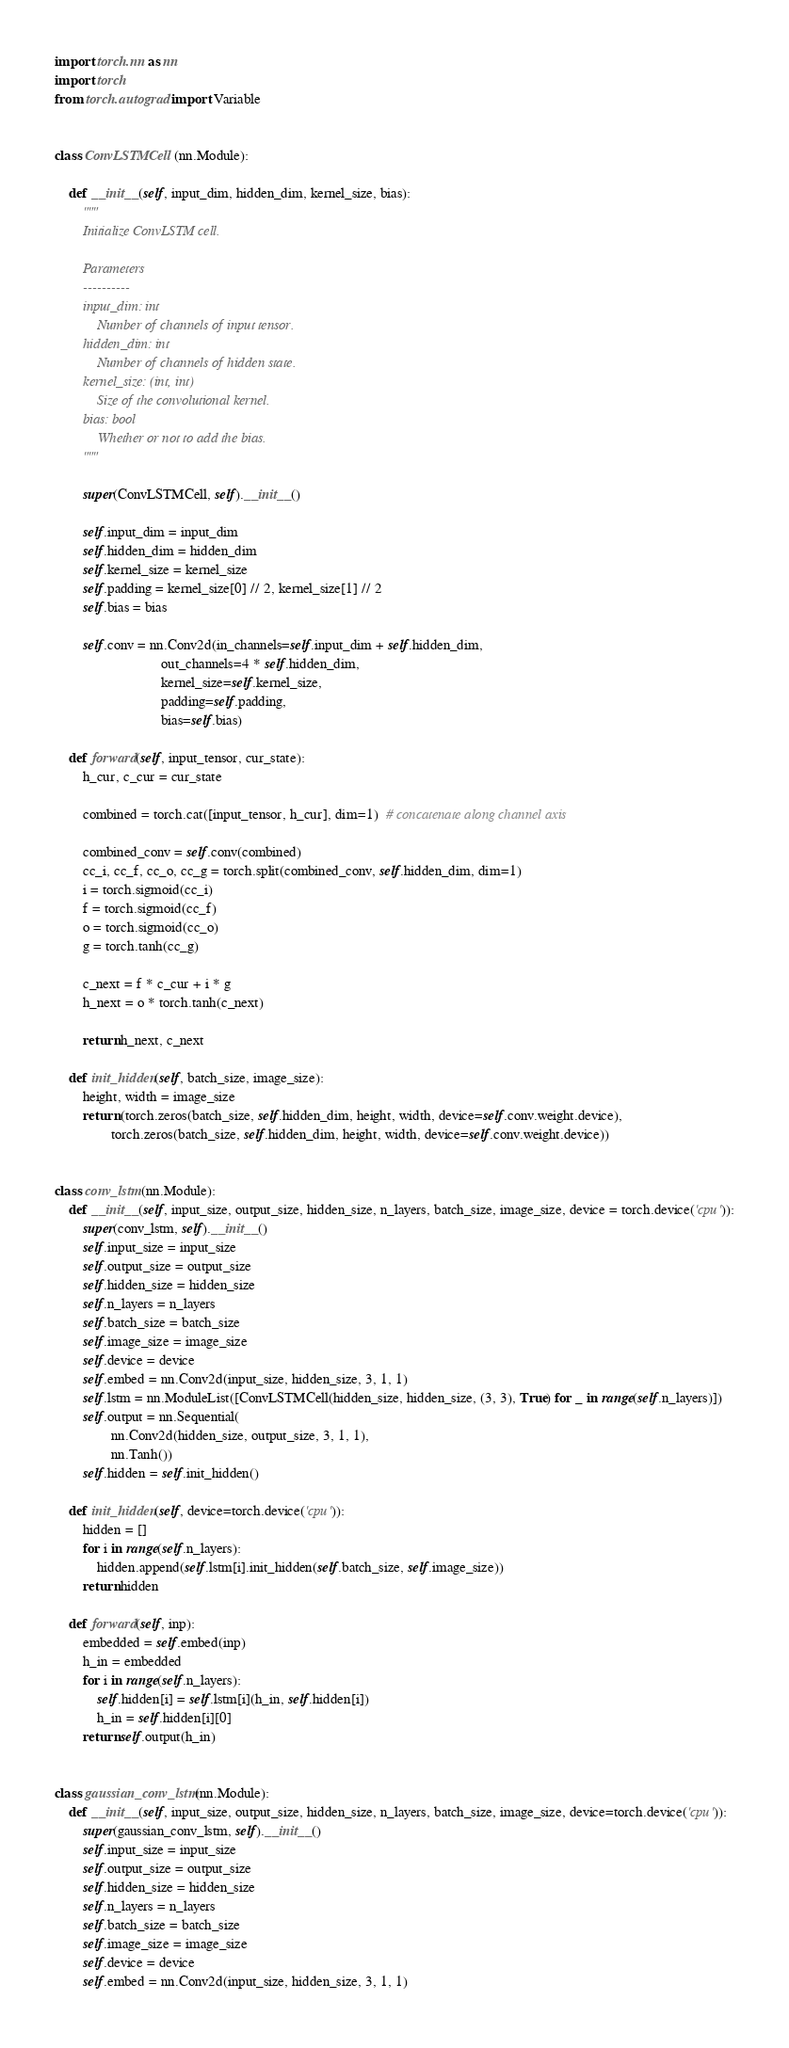<code> <loc_0><loc_0><loc_500><loc_500><_Python_>import torch.nn as nn
import torch
from torch.autograd import Variable


class ConvLSTMCell(nn.Module):

    def __init__(self, input_dim, hidden_dim, kernel_size, bias):
        """
        Initialize ConvLSTM cell.

        Parameters
        ----------
        input_dim: int
            Number of channels of input tensor.
        hidden_dim: int
            Number of channels of hidden state.
        kernel_size: (int, int)
            Size of the convolutional kernel.
        bias: bool
            Whether or not to add the bias.
        """

        super(ConvLSTMCell, self).__init__()

        self.input_dim = input_dim
        self.hidden_dim = hidden_dim
        self.kernel_size = kernel_size
        self.padding = kernel_size[0] // 2, kernel_size[1] // 2
        self.bias = bias

        self.conv = nn.Conv2d(in_channels=self.input_dim + self.hidden_dim,
                              out_channels=4 * self.hidden_dim,
                              kernel_size=self.kernel_size,
                              padding=self.padding,
                              bias=self.bias)

    def forward(self, input_tensor, cur_state):
        h_cur, c_cur = cur_state

        combined = torch.cat([input_tensor, h_cur], dim=1)  # concatenate along channel axis

        combined_conv = self.conv(combined)
        cc_i, cc_f, cc_o, cc_g = torch.split(combined_conv, self.hidden_dim, dim=1)
        i = torch.sigmoid(cc_i)
        f = torch.sigmoid(cc_f)
        o = torch.sigmoid(cc_o)
        g = torch.tanh(cc_g)

        c_next = f * c_cur + i * g
        h_next = o * torch.tanh(c_next)

        return h_next, c_next

    def init_hidden(self, batch_size, image_size):
        height, width = image_size
        return (torch.zeros(batch_size, self.hidden_dim, height, width, device=self.conv.weight.device),
                torch.zeros(batch_size, self.hidden_dim, height, width, device=self.conv.weight.device))


class conv_lstm(nn.Module):
    def __init__(self, input_size, output_size, hidden_size, n_layers, batch_size, image_size, device = torch.device('cpu')):
        super(conv_lstm, self).__init__()
        self.input_size = input_size
        self.output_size = output_size
        self.hidden_size = hidden_size
        self.n_layers = n_layers
        self.batch_size = batch_size
        self.image_size = image_size
        self.device = device
        self.embed = nn.Conv2d(input_size, hidden_size, 3, 1, 1)
        self.lstm = nn.ModuleList([ConvLSTMCell(hidden_size, hidden_size, (3, 3), True) for _ in range(self.n_layers)])
        self.output = nn.Sequential(
                nn.Conv2d(hidden_size, output_size, 3, 1, 1),
                nn.Tanh())
        self.hidden = self.init_hidden()

    def init_hidden(self, device=torch.device('cpu')):
        hidden = []
        for i in range(self.n_layers):
            hidden.append(self.lstm[i].init_hidden(self.batch_size, self.image_size))
        return hidden

    def forward(self, inp):
        embedded = self.embed(inp)
        h_in = embedded
        for i in range(self.n_layers):
            self.hidden[i] = self.lstm[i](h_in, self.hidden[i])
            h_in = self.hidden[i][0]
        return self.output(h_in)


class gaussian_conv_lstm(nn.Module):
    def __init__(self, input_size, output_size, hidden_size, n_layers, batch_size, image_size, device=torch.device('cpu')):
        super(gaussian_conv_lstm, self).__init__()
        self.input_size = input_size
        self.output_size = output_size
        self.hidden_size = hidden_size
        self.n_layers = n_layers
        self.batch_size = batch_size
        self.image_size = image_size
        self.device = device
        self.embed = nn.Conv2d(input_size, hidden_size, 3, 1, 1)</code> 